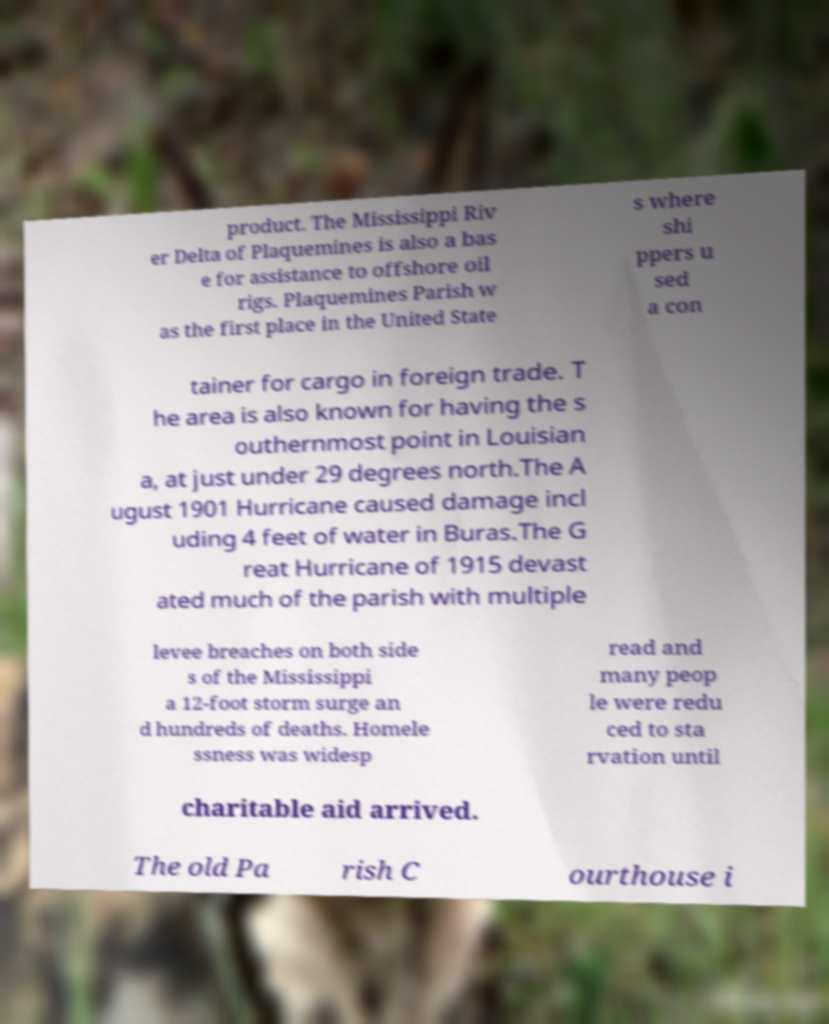I need the written content from this picture converted into text. Can you do that? product. The Mississippi Riv er Delta of Plaquemines is also a bas e for assistance to offshore oil rigs. Plaquemines Parish w as the first place in the United State s where shi ppers u sed a con tainer for cargo in foreign trade. T he area is also known for having the s outhernmost point in Louisian a, at just under 29 degrees north.The A ugust 1901 Hurricane caused damage incl uding 4 feet of water in Buras.The G reat Hurricane of 1915 devast ated much of the parish with multiple levee breaches on both side s of the Mississippi a 12-foot storm surge an d hundreds of deaths. Homele ssness was widesp read and many peop le were redu ced to sta rvation until charitable aid arrived. The old Pa rish C ourthouse i 